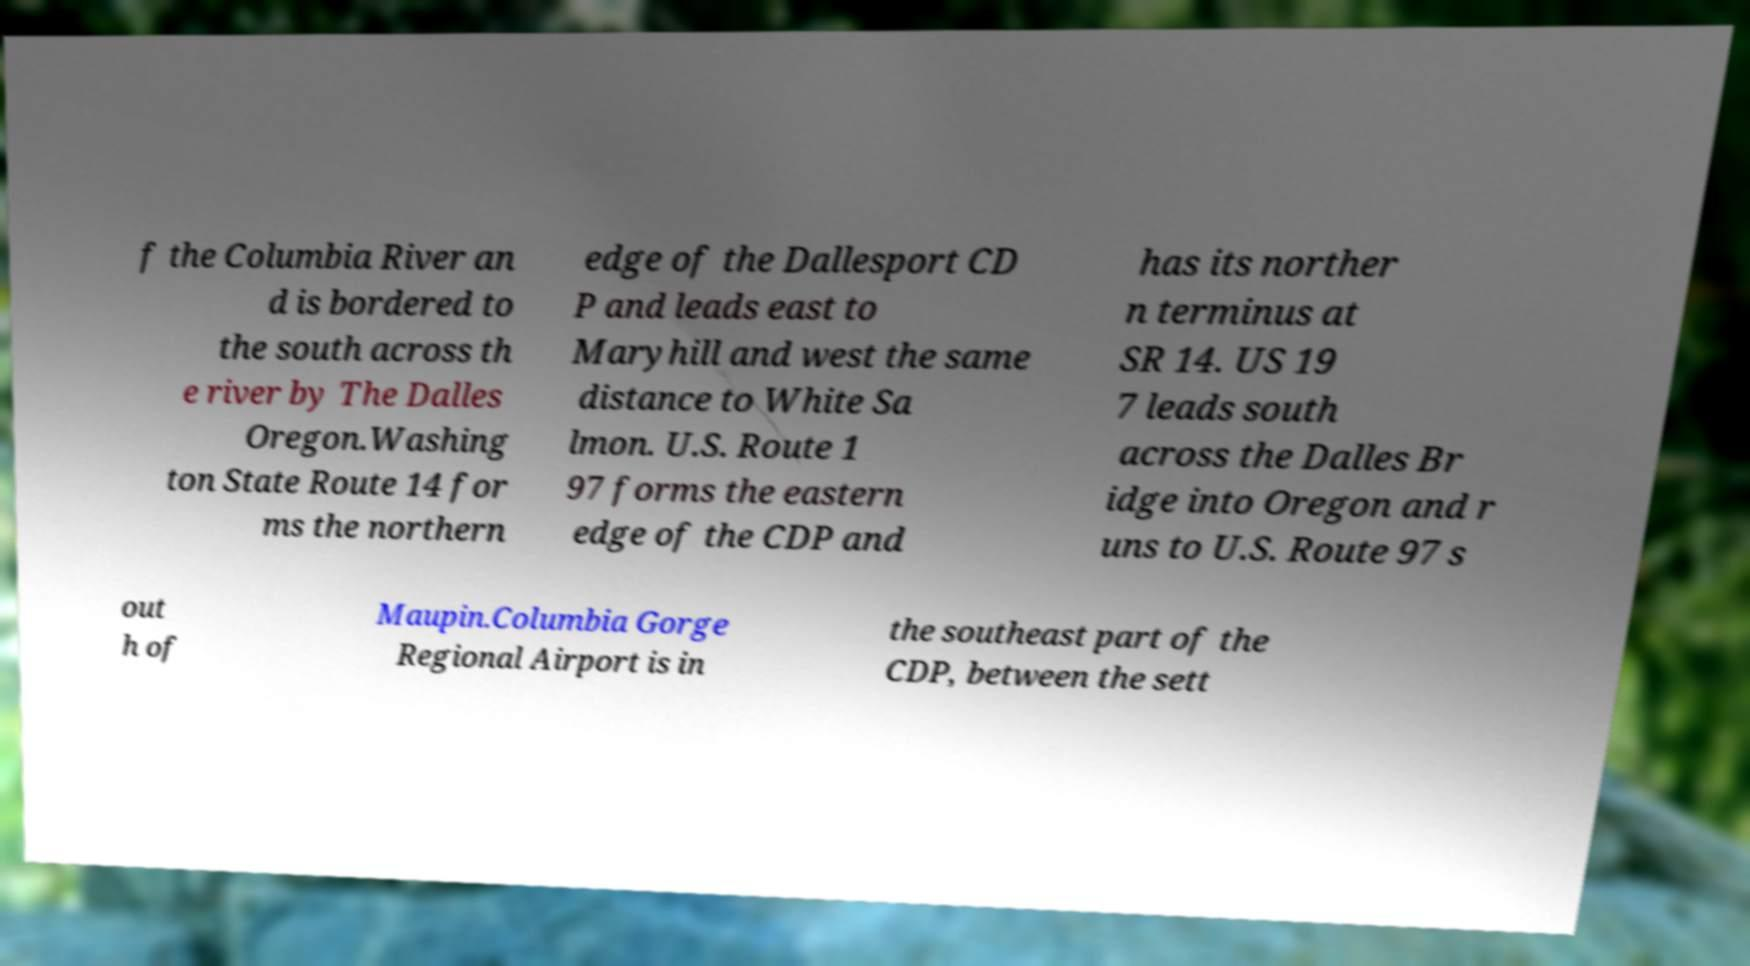Please identify and transcribe the text found in this image. f the Columbia River an d is bordered to the south across th e river by The Dalles Oregon.Washing ton State Route 14 for ms the northern edge of the Dallesport CD P and leads east to Maryhill and west the same distance to White Sa lmon. U.S. Route 1 97 forms the eastern edge of the CDP and has its norther n terminus at SR 14. US 19 7 leads south across the Dalles Br idge into Oregon and r uns to U.S. Route 97 s out h of Maupin.Columbia Gorge Regional Airport is in the southeast part of the CDP, between the sett 